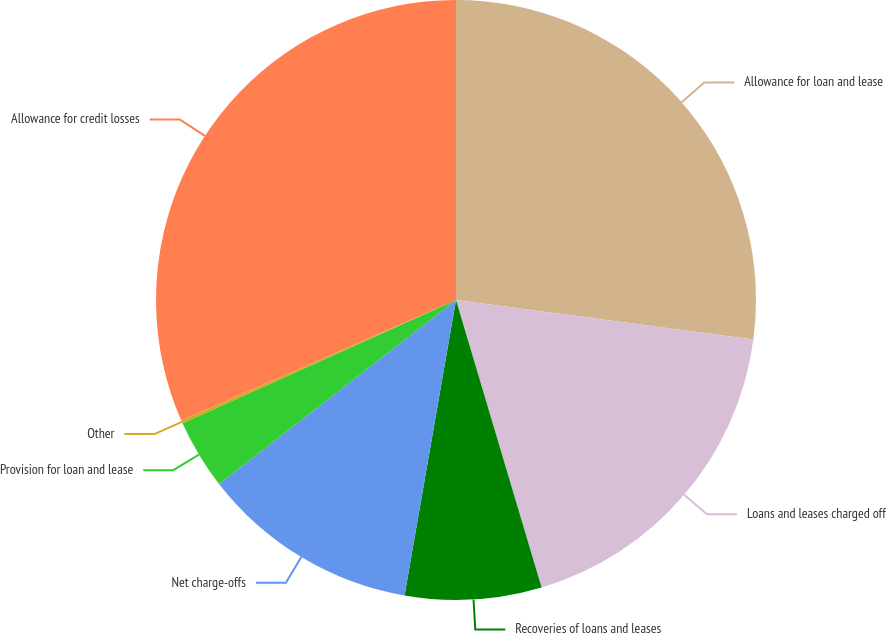Convert chart to OTSL. <chart><loc_0><loc_0><loc_500><loc_500><pie_chart><fcel>Allowance for loan and lease<fcel>Loans and leases charged off<fcel>Recoveries of loans and leases<fcel>Net charge-offs<fcel>Provision for loan and lease<fcel>Other<fcel>Allowance for credit losses<nl><fcel>27.1%<fcel>18.29%<fcel>7.35%<fcel>11.75%<fcel>3.76%<fcel>0.17%<fcel>31.57%<nl></chart> 